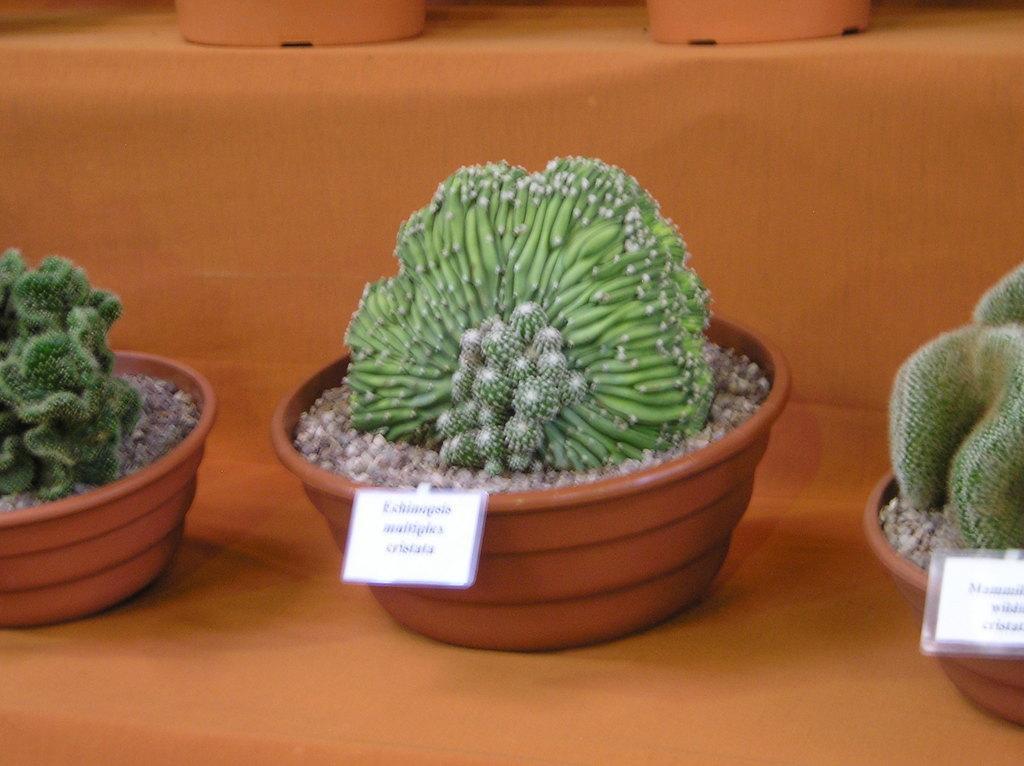In one or two sentences, can you explain what this image depicts? In this picture we can see cactus plants and stones in the flower pots, which are on the surface. To the flower pots there are boards. At the top of the image, there are some objects. 